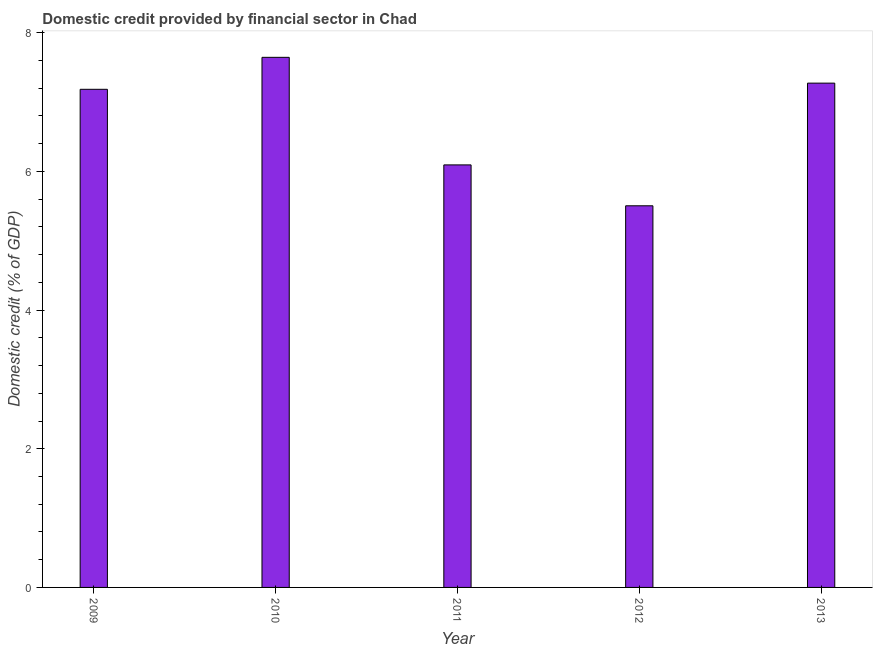Does the graph contain any zero values?
Your answer should be very brief. No. Does the graph contain grids?
Your answer should be compact. No. What is the title of the graph?
Provide a short and direct response. Domestic credit provided by financial sector in Chad. What is the label or title of the X-axis?
Offer a very short reply. Year. What is the label or title of the Y-axis?
Offer a very short reply. Domestic credit (% of GDP). What is the domestic credit provided by financial sector in 2009?
Keep it short and to the point. 7.18. Across all years, what is the maximum domestic credit provided by financial sector?
Offer a terse response. 7.65. Across all years, what is the minimum domestic credit provided by financial sector?
Keep it short and to the point. 5.5. In which year was the domestic credit provided by financial sector maximum?
Ensure brevity in your answer.  2010. What is the sum of the domestic credit provided by financial sector?
Your response must be concise. 33.7. What is the difference between the domestic credit provided by financial sector in 2009 and 2013?
Make the answer very short. -0.09. What is the average domestic credit provided by financial sector per year?
Offer a very short reply. 6.74. What is the median domestic credit provided by financial sector?
Make the answer very short. 7.18. Do a majority of the years between 2010 and 2012 (inclusive) have domestic credit provided by financial sector greater than 5.2 %?
Keep it short and to the point. Yes. What is the ratio of the domestic credit provided by financial sector in 2012 to that in 2013?
Make the answer very short. 0.76. What is the difference between the highest and the second highest domestic credit provided by financial sector?
Your answer should be very brief. 0.37. Is the sum of the domestic credit provided by financial sector in 2011 and 2012 greater than the maximum domestic credit provided by financial sector across all years?
Provide a succinct answer. Yes. What is the difference between the highest and the lowest domestic credit provided by financial sector?
Your response must be concise. 2.14. In how many years, is the domestic credit provided by financial sector greater than the average domestic credit provided by financial sector taken over all years?
Your answer should be very brief. 3. How many bars are there?
Your answer should be very brief. 5. Are all the bars in the graph horizontal?
Ensure brevity in your answer.  No. How many years are there in the graph?
Your answer should be compact. 5. What is the difference between two consecutive major ticks on the Y-axis?
Ensure brevity in your answer.  2. Are the values on the major ticks of Y-axis written in scientific E-notation?
Your answer should be compact. No. What is the Domestic credit (% of GDP) of 2009?
Offer a terse response. 7.18. What is the Domestic credit (% of GDP) in 2010?
Keep it short and to the point. 7.65. What is the Domestic credit (% of GDP) in 2011?
Offer a very short reply. 6.09. What is the Domestic credit (% of GDP) of 2012?
Provide a short and direct response. 5.5. What is the Domestic credit (% of GDP) of 2013?
Offer a very short reply. 7.27. What is the difference between the Domestic credit (% of GDP) in 2009 and 2010?
Offer a terse response. -0.46. What is the difference between the Domestic credit (% of GDP) in 2009 and 2011?
Offer a very short reply. 1.09. What is the difference between the Domestic credit (% of GDP) in 2009 and 2012?
Give a very brief answer. 1.68. What is the difference between the Domestic credit (% of GDP) in 2009 and 2013?
Ensure brevity in your answer.  -0.09. What is the difference between the Domestic credit (% of GDP) in 2010 and 2011?
Your response must be concise. 1.55. What is the difference between the Domestic credit (% of GDP) in 2010 and 2012?
Provide a short and direct response. 2.14. What is the difference between the Domestic credit (% of GDP) in 2010 and 2013?
Offer a terse response. 0.37. What is the difference between the Domestic credit (% of GDP) in 2011 and 2012?
Keep it short and to the point. 0.59. What is the difference between the Domestic credit (% of GDP) in 2011 and 2013?
Ensure brevity in your answer.  -1.18. What is the difference between the Domestic credit (% of GDP) in 2012 and 2013?
Your response must be concise. -1.77. What is the ratio of the Domestic credit (% of GDP) in 2009 to that in 2011?
Offer a terse response. 1.18. What is the ratio of the Domestic credit (% of GDP) in 2009 to that in 2012?
Keep it short and to the point. 1.3. What is the ratio of the Domestic credit (% of GDP) in 2010 to that in 2011?
Provide a succinct answer. 1.25. What is the ratio of the Domestic credit (% of GDP) in 2010 to that in 2012?
Make the answer very short. 1.39. What is the ratio of the Domestic credit (% of GDP) in 2010 to that in 2013?
Provide a succinct answer. 1.05. What is the ratio of the Domestic credit (% of GDP) in 2011 to that in 2012?
Keep it short and to the point. 1.11. What is the ratio of the Domestic credit (% of GDP) in 2011 to that in 2013?
Your response must be concise. 0.84. What is the ratio of the Domestic credit (% of GDP) in 2012 to that in 2013?
Keep it short and to the point. 0.76. 